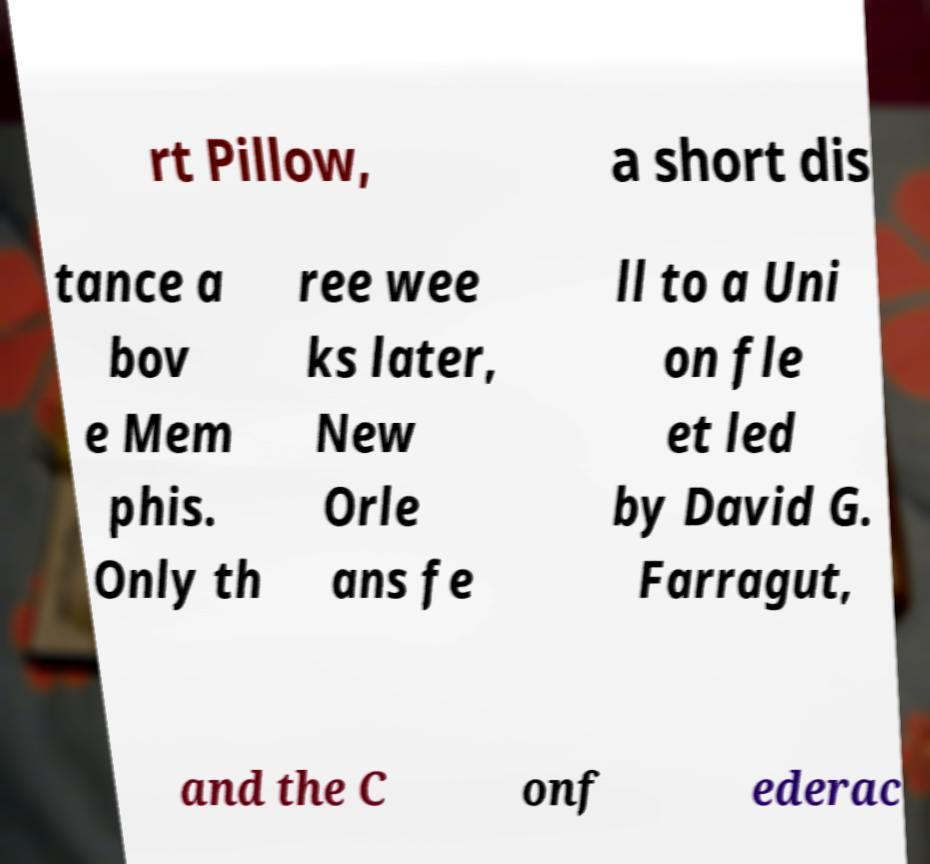Could you assist in decoding the text presented in this image and type it out clearly? rt Pillow, a short dis tance a bov e Mem phis. Only th ree wee ks later, New Orle ans fe ll to a Uni on fle et led by David G. Farragut, and the C onf ederac 